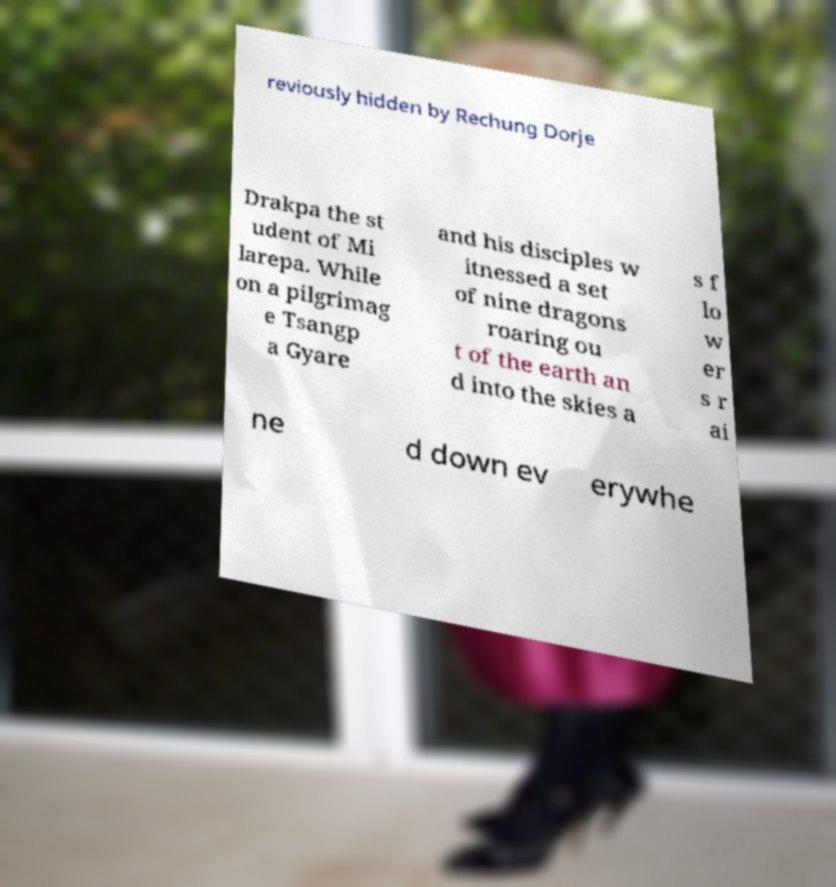Please read and relay the text visible in this image. What does it say? reviously hidden by Rechung Dorje Drakpa the st udent of Mi larepa. While on a pilgrimag e Tsangp a Gyare and his disciples w itnessed a set of nine dragons roaring ou t of the earth an d into the skies a s f lo w er s r ai ne d down ev erywhe 